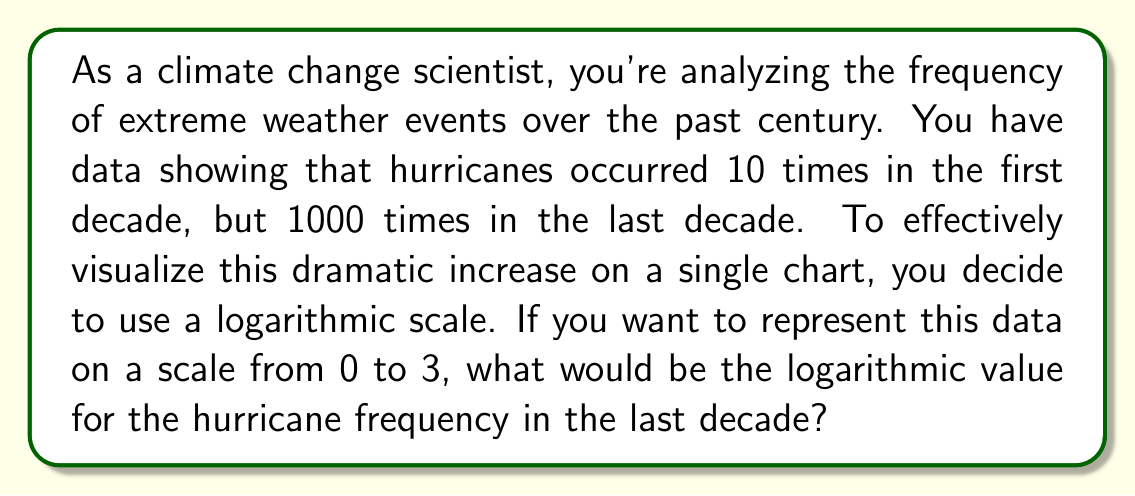What is the answer to this math problem? Let's approach this step-by-step:

1) We're dealing with a logarithmic scale from 0 to 3. This suggests we're using log base 10, as $\log_{10}(1000) = 3$.

2) The general formula for converting a value to a logarithmic scale is:
   $$\text{Logarithmic value} = \log_{10}(\text{Actual value})$$

3) For the hurricane frequency in the last decade:
   $$\text{Logarithmic value} = \log_{10}(1000)$$

4) We can calculate this:
   $$\log_{10}(1000) = 3$$

5) This fits perfectly on our 0 to 3 scale, where:
   - 0 represents $10^0 = 1$ event
   - 1 represents $10^1 = 10$ events
   - 2 represents $10^2 = 100$ events
   - 3 represents $10^3 = 1000$ events

Therefore, the logarithmic value for 1000 hurricanes on this scale is 3.
Answer: 3 